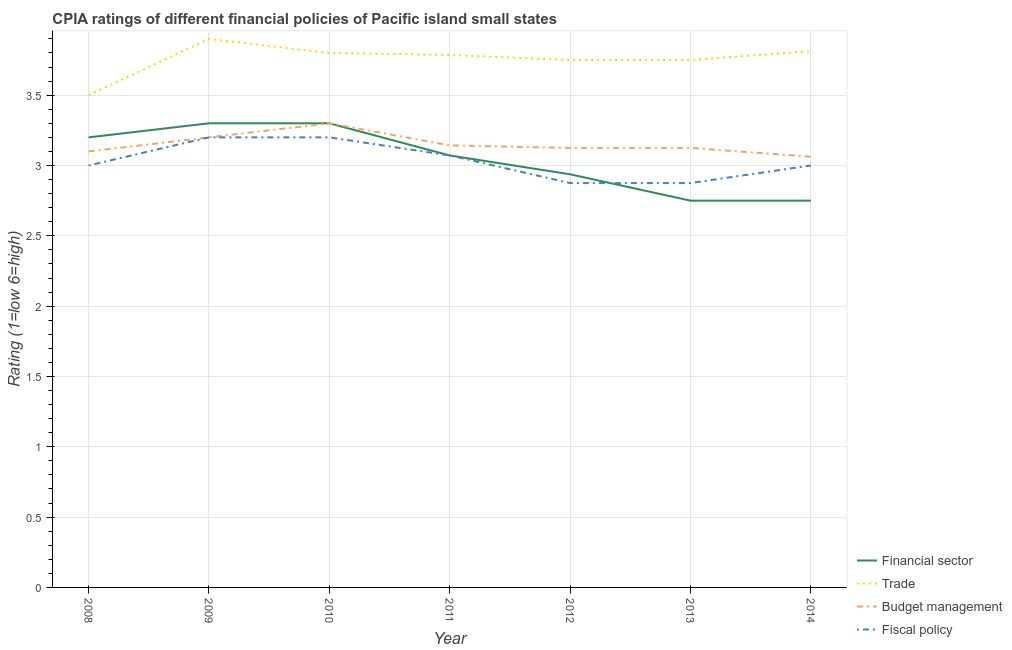How many different coloured lines are there?
Make the answer very short. 4. Is the number of lines equal to the number of legend labels?
Your response must be concise. Yes. Across all years, what is the maximum cpia rating of fiscal policy?
Ensure brevity in your answer.  3.2. What is the total cpia rating of budget management in the graph?
Ensure brevity in your answer.  22.06. What is the difference between the cpia rating of fiscal policy in 2009 and that in 2013?
Provide a succinct answer. 0.33. What is the difference between the cpia rating of fiscal policy in 2009 and the cpia rating of trade in 2010?
Offer a very short reply. -0.6. What is the average cpia rating of financial sector per year?
Your response must be concise. 3.04. In the year 2010, what is the difference between the cpia rating of fiscal policy and cpia rating of financial sector?
Provide a succinct answer. -0.1. What is the ratio of the cpia rating of budget management in 2010 to that in 2012?
Offer a terse response. 1.06. Is the cpia rating of trade in 2011 less than that in 2013?
Make the answer very short. No. Is the difference between the cpia rating of financial sector in 2008 and 2011 greater than the difference between the cpia rating of trade in 2008 and 2011?
Ensure brevity in your answer.  Yes. What is the difference between the highest and the second highest cpia rating of trade?
Your answer should be very brief. 0.09. What is the difference between the highest and the lowest cpia rating of financial sector?
Keep it short and to the point. 0.55. Is the sum of the cpia rating of budget management in 2010 and 2012 greater than the maximum cpia rating of fiscal policy across all years?
Make the answer very short. Yes. Is it the case that in every year, the sum of the cpia rating of financial sector and cpia rating of trade is greater than the cpia rating of budget management?
Your answer should be compact. Yes. Does the cpia rating of fiscal policy monotonically increase over the years?
Offer a very short reply. No. Is the cpia rating of trade strictly less than the cpia rating of financial sector over the years?
Offer a very short reply. No. How many years are there in the graph?
Make the answer very short. 7. Does the graph contain grids?
Your answer should be very brief. Yes. Where does the legend appear in the graph?
Keep it short and to the point. Bottom right. How are the legend labels stacked?
Offer a very short reply. Vertical. What is the title of the graph?
Offer a very short reply. CPIA ratings of different financial policies of Pacific island small states. Does "Finland" appear as one of the legend labels in the graph?
Offer a very short reply. No. What is the label or title of the X-axis?
Keep it short and to the point. Year. What is the label or title of the Y-axis?
Your answer should be compact. Rating (1=low 6=high). What is the Rating (1=low 6=high) in Budget management in 2008?
Your answer should be compact. 3.1. What is the Rating (1=low 6=high) of Budget management in 2009?
Your response must be concise. 3.2. What is the Rating (1=low 6=high) of Fiscal policy in 2009?
Make the answer very short. 3.2. What is the Rating (1=low 6=high) of Financial sector in 2010?
Make the answer very short. 3.3. What is the Rating (1=low 6=high) of Budget management in 2010?
Your answer should be very brief. 3.3. What is the Rating (1=low 6=high) in Fiscal policy in 2010?
Offer a terse response. 3.2. What is the Rating (1=low 6=high) of Financial sector in 2011?
Offer a very short reply. 3.07. What is the Rating (1=low 6=high) of Trade in 2011?
Offer a very short reply. 3.79. What is the Rating (1=low 6=high) of Budget management in 2011?
Offer a very short reply. 3.14. What is the Rating (1=low 6=high) in Fiscal policy in 2011?
Offer a terse response. 3.07. What is the Rating (1=low 6=high) in Financial sector in 2012?
Your response must be concise. 2.94. What is the Rating (1=low 6=high) of Trade in 2012?
Your answer should be very brief. 3.75. What is the Rating (1=low 6=high) in Budget management in 2012?
Your answer should be compact. 3.12. What is the Rating (1=low 6=high) in Fiscal policy in 2012?
Provide a short and direct response. 2.88. What is the Rating (1=low 6=high) of Financial sector in 2013?
Offer a terse response. 2.75. What is the Rating (1=low 6=high) in Trade in 2013?
Offer a very short reply. 3.75. What is the Rating (1=low 6=high) of Budget management in 2013?
Your answer should be very brief. 3.12. What is the Rating (1=low 6=high) in Fiscal policy in 2013?
Offer a very short reply. 2.88. What is the Rating (1=low 6=high) of Financial sector in 2014?
Provide a succinct answer. 2.75. What is the Rating (1=low 6=high) of Trade in 2014?
Your answer should be compact. 3.81. What is the Rating (1=low 6=high) in Budget management in 2014?
Give a very brief answer. 3.06. Across all years, what is the maximum Rating (1=low 6=high) of Financial sector?
Offer a very short reply. 3.3. Across all years, what is the maximum Rating (1=low 6=high) in Budget management?
Make the answer very short. 3.3. Across all years, what is the minimum Rating (1=low 6=high) of Financial sector?
Your answer should be compact. 2.75. Across all years, what is the minimum Rating (1=low 6=high) of Trade?
Ensure brevity in your answer.  3.5. Across all years, what is the minimum Rating (1=low 6=high) of Budget management?
Provide a short and direct response. 3.06. Across all years, what is the minimum Rating (1=low 6=high) of Fiscal policy?
Offer a very short reply. 2.88. What is the total Rating (1=low 6=high) of Financial sector in the graph?
Your answer should be compact. 21.31. What is the total Rating (1=low 6=high) of Trade in the graph?
Offer a terse response. 26.3. What is the total Rating (1=low 6=high) in Budget management in the graph?
Offer a very short reply. 22.06. What is the total Rating (1=low 6=high) of Fiscal policy in the graph?
Make the answer very short. 21.22. What is the difference between the Rating (1=low 6=high) in Financial sector in 2008 and that in 2009?
Your answer should be compact. -0.1. What is the difference between the Rating (1=low 6=high) in Fiscal policy in 2008 and that in 2009?
Your answer should be very brief. -0.2. What is the difference between the Rating (1=low 6=high) in Budget management in 2008 and that in 2010?
Your answer should be compact. -0.2. What is the difference between the Rating (1=low 6=high) in Fiscal policy in 2008 and that in 2010?
Offer a very short reply. -0.2. What is the difference between the Rating (1=low 6=high) in Financial sector in 2008 and that in 2011?
Your answer should be compact. 0.13. What is the difference between the Rating (1=low 6=high) in Trade in 2008 and that in 2011?
Offer a very short reply. -0.29. What is the difference between the Rating (1=low 6=high) in Budget management in 2008 and that in 2011?
Make the answer very short. -0.04. What is the difference between the Rating (1=low 6=high) of Fiscal policy in 2008 and that in 2011?
Offer a terse response. -0.07. What is the difference between the Rating (1=low 6=high) of Financial sector in 2008 and that in 2012?
Offer a very short reply. 0.26. What is the difference between the Rating (1=low 6=high) of Trade in 2008 and that in 2012?
Ensure brevity in your answer.  -0.25. What is the difference between the Rating (1=low 6=high) in Budget management in 2008 and that in 2012?
Your answer should be compact. -0.03. What is the difference between the Rating (1=low 6=high) of Financial sector in 2008 and that in 2013?
Provide a short and direct response. 0.45. What is the difference between the Rating (1=low 6=high) of Budget management in 2008 and that in 2013?
Provide a short and direct response. -0.03. What is the difference between the Rating (1=low 6=high) of Financial sector in 2008 and that in 2014?
Provide a short and direct response. 0.45. What is the difference between the Rating (1=low 6=high) of Trade in 2008 and that in 2014?
Your response must be concise. -0.31. What is the difference between the Rating (1=low 6=high) of Budget management in 2008 and that in 2014?
Offer a very short reply. 0.04. What is the difference between the Rating (1=low 6=high) of Fiscal policy in 2008 and that in 2014?
Your answer should be very brief. 0. What is the difference between the Rating (1=low 6=high) of Trade in 2009 and that in 2010?
Keep it short and to the point. 0.1. What is the difference between the Rating (1=low 6=high) in Financial sector in 2009 and that in 2011?
Your response must be concise. 0.23. What is the difference between the Rating (1=low 6=high) of Trade in 2009 and that in 2011?
Your response must be concise. 0.11. What is the difference between the Rating (1=low 6=high) in Budget management in 2009 and that in 2011?
Give a very brief answer. 0.06. What is the difference between the Rating (1=low 6=high) in Fiscal policy in 2009 and that in 2011?
Keep it short and to the point. 0.13. What is the difference between the Rating (1=low 6=high) in Financial sector in 2009 and that in 2012?
Your answer should be very brief. 0.36. What is the difference between the Rating (1=low 6=high) of Budget management in 2009 and that in 2012?
Keep it short and to the point. 0.07. What is the difference between the Rating (1=low 6=high) of Fiscal policy in 2009 and that in 2012?
Provide a short and direct response. 0.33. What is the difference between the Rating (1=low 6=high) of Financial sector in 2009 and that in 2013?
Keep it short and to the point. 0.55. What is the difference between the Rating (1=low 6=high) in Trade in 2009 and that in 2013?
Your answer should be compact. 0.15. What is the difference between the Rating (1=low 6=high) of Budget management in 2009 and that in 2013?
Your answer should be compact. 0.07. What is the difference between the Rating (1=low 6=high) in Fiscal policy in 2009 and that in 2013?
Your response must be concise. 0.33. What is the difference between the Rating (1=low 6=high) of Financial sector in 2009 and that in 2014?
Your answer should be very brief. 0.55. What is the difference between the Rating (1=low 6=high) of Trade in 2009 and that in 2014?
Give a very brief answer. 0.09. What is the difference between the Rating (1=low 6=high) of Budget management in 2009 and that in 2014?
Your response must be concise. 0.14. What is the difference between the Rating (1=low 6=high) in Fiscal policy in 2009 and that in 2014?
Ensure brevity in your answer.  0.2. What is the difference between the Rating (1=low 6=high) of Financial sector in 2010 and that in 2011?
Make the answer very short. 0.23. What is the difference between the Rating (1=low 6=high) of Trade in 2010 and that in 2011?
Provide a short and direct response. 0.01. What is the difference between the Rating (1=low 6=high) of Budget management in 2010 and that in 2011?
Your answer should be compact. 0.16. What is the difference between the Rating (1=low 6=high) of Fiscal policy in 2010 and that in 2011?
Keep it short and to the point. 0.13. What is the difference between the Rating (1=low 6=high) in Financial sector in 2010 and that in 2012?
Your answer should be very brief. 0.36. What is the difference between the Rating (1=low 6=high) in Budget management in 2010 and that in 2012?
Keep it short and to the point. 0.17. What is the difference between the Rating (1=low 6=high) in Fiscal policy in 2010 and that in 2012?
Ensure brevity in your answer.  0.33. What is the difference between the Rating (1=low 6=high) in Financial sector in 2010 and that in 2013?
Keep it short and to the point. 0.55. What is the difference between the Rating (1=low 6=high) of Trade in 2010 and that in 2013?
Give a very brief answer. 0.05. What is the difference between the Rating (1=low 6=high) in Budget management in 2010 and that in 2013?
Offer a very short reply. 0.17. What is the difference between the Rating (1=low 6=high) of Fiscal policy in 2010 and that in 2013?
Ensure brevity in your answer.  0.33. What is the difference between the Rating (1=low 6=high) in Financial sector in 2010 and that in 2014?
Provide a succinct answer. 0.55. What is the difference between the Rating (1=low 6=high) of Trade in 2010 and that in 2014?
Make the answer very short. -0.01. What is the difference between the Rating (1=low 6=high) of Budget management in 2010 and that in 2014?
Make the answer very short. 0.24. What is the difference between the Rating (1=low 6=high) of Fiscal policy in 2010 and that in 2014?
Provide a succinct answer. 0.2. What is the difference between the Rating (1=low 6=high) in Financial sector in 2011 and that in 2012?
Make the answer very short. 0.13. What is the difference between the Rating (1=low 6=high) of Trade in 2011 and that in 2012?
Make the answer very short. 0.04. What is the difference between the Rating (1=low 6=high) in Budget management in 2011 and that in 2012?
Offer a very short reply. 0.02. What is the difference between the Rating (1=low 6=high) in Fiscal policy in 2011 and that in 2012?
Ensure brevity in your answer.  0.2. What is the difference between the Rating (1=low 6=high) of Financial sector in 2011 and that in 2013?
Keep it short and to the point. 0.32. What is the difference between the Rating (1=low 6=high) in Trade in 2011 and that in 2013?
Provide a succinct answer. 0.04. What is the difference between the Rating (1=low 6=high) of Budget management in 2011 and that in 2013?
Provide a short and direct response. 0.02. What is the difference between the Rating (1=low 6=high) of Fiscal policy in 2011 and that in 2013?
Your answer should be very brief. 0.2. What is the difference between the Rating (1=low 6=high) of Financial sector in 2011 and that in 2014?
Your response must be concise. 0.32. What is the difference between the Rating (1=low 6=high) of Trade in 2011 and that in 2014?
Your answer should be very brief. -0.03. What is the difference between the Rating (1=low 6=high) of Budget management in 2011 and that in 2014?
Your answer should be compact. 0.08. What is the difference between the Rating (1=low 6=high) in Fiscal policy in 2011 and that in 2014?
Your answer should be very brief. 0.07. What is the difference between the Rating (1=low 6=high) of Financial sector in 2012 and that in 2013?
Offer a terse response. 0.19. What is the difference between the Rating (1=low 6=high) of Fiscal policy in 2012 and that in 2013?
Offer a terse response. 0. What is the difference between the Rating (1=low 6=high) in Financial sector in 2012 and that in 2014?
Provide a succinct answer. 0.19. What is the difference between the Rating (1=low 6=high) in Trade in 2012 and that in 2014?
Offer a very short reply. -0.06. What is the difference between the Rating (1=low 6=high) in Budget management in 2012 and that in 2014?
Give a very brief answer. 0.06. What is the difference between the Rating (1=low 6=high) in Fiscal policy in 2012 and that in 2014?
Offer a terse response. -0.12. What is the difference between the Rating (1=low 6=high) in Trade in 2013 and that in 2014?
Offer a very short reply. -0.06. What is the difference between the Rating (1=low 6=high) of Budget management in 2013 and that in 2014?
Offer a terse response. 0.06. What is the difference between the Rating (1=low 6=high) of Fiscal policy in 2013 and that in 2014?
Provide a short and direct response. -0.12. What is the difference between the Rating (1=low 6=high) of Financial sector in 2008 and the Rating (1=low 6=high) of Budget management in 2009?
Offer a terse response. 0. What is the difference between the Rating (1=low 6=high) in Financial sector in 2008 and the Rating (1=low 6=high) in Fiscal policy in 2009?
Give a very brief answer. 0. What is the difference between the Rating (1=low 6=high) of Trade in 2008 and the Rating (1=low 6=high) of Fiscal policy in 2009?
Your answer should be compact. 0.3. What is the difference between the Rating (1=low 6=high) in Financial sector in 2008 and the Rating (1=low 6=high) in Fiscal policy in 2010?
Offer a very short reply. 0. What is the difference between the Rating (1=low 6=high) in Trade in 2008 and the Rating (1=low 6=high) in Budget management in 2010?
Your answer should be very brief. 0.2. What is the difference between the Rating (1=low 6=high) in Trade in 2008 and the Rating (1=low 6=high) in Fiscal policy in 2010?
Provide a short and direct response. 0.3. What is the difference between the Rating (1=low 6=high) of Financial sector in 2008 and the Rating (1=low 6=high) of Trade in 2011?
Ensure brevity in your answer.  -0.59. What is the difference between the Rating (1=low 6=high) of Financial sector in 2008 and the Rating (1=low 6=high) of Budget management in 2011?
Your response must be concise. 0.06. What is the difference between the Rating (1=low 6=high) in Financial sector in 2008 and the Rating (1=low 6=high) in Fiscal policy in 2011?
Offer a very short reply. 0.13. What is the difference between the Rating (1=low 6=high) of Trade in 2008 and the Rating (1=low 6=high) of Budget management in 2011?
Ensure brevity in your answer.  0.36. What is the difference between the Rating (1=low 6=high) of Trade in 2008 and the Rating (1=low 6=high) of Fiscal policy in 2011?
Your answer should be very brief. 0.43. What is the difference between the Rating (1=low 6=high) of Budget management in 2008 and the Rating (1=low 6=high) of Fiscal policy in 2011?
Provide a short and direct response. 0.03. What is the difference between the Rating (1=low 6=high) of Financial sector in 2008 and the Rating (1=low 6=high) of Trade in 2012?
Your response must be concise. -0.55. What is the difference between the Rating (1=low 6=high) of Financial sector in 2008 and the Rating (1=low 6=high) of Budget management in 2012?
Make the answer very short. 0.07. What is the difference between the Rating (1=low 6=high) in Financial sector in 2008 and the Rating (1=low 6=high) in Fiscal policy in 2012?
Provide a succinct answer. 0.33. What is the difference between the Rating (1=low 6=high) of Trade in 2008 and the Rating (1=low 6=high) of Fiscal policy in 2012?
Offer a very short reply. 0.62. What is the difference between the Rating (1=low 6=high) of Budget management in 2008 and the Rating (1=low 6=high) of Fiscal policy in 2012?
Offer a very short reply. 0.23. What is the difference between the Rating (1=low 6=high) in Financial sector in 2008 and the Rating (1=low 6=high) in Trade in 2013?
Make the answer very short. -0.55. What is the difference between the Rating (1=low 6=high) of Financial sector in 2008 and the Rating (1=low 6=high) of Budget management in 2013?
Offer a terse response. 0.07. What is the difference between the Rating (1=low 6=high) in Financial sector in 2008 and the Rating (1=low 6=high) in Fiscal policy in 2013?
Your answer should be very brief. 0.33. What is the difference between the Rating (1=low 6=high) of Trade in 2008 and the Rating (1=low 6=high) of Fiscal policy in 2013?
Your answer should be compact. 0.62. What is the difference between the Rating (1=low 6=high) in Budget management in 2008 and the Rating (1=low 6=high) in Fiscal policy in 2013?
Provide a succinct answer. 0.23. What is the difference between the Rating (1=low 6=high) in Financial sector in 2008 and the Rating (1=low 6=high) in Trade in 2014?
Your response must be concise. -0.61. What is the difference between the Rating (1=low 6=high) in Financial sector in 2008 and the Rating (1=low 6=high) in Budget management in 2014?
Offer a terse response. 0.14. What is the difference between the Rating (1=low 6=high) of Trade in 2008 and the Rating (1=low 6=high) of Budget management in 2014?
Keep it short and to the point. 0.44. What is the difference between the Rating (1=low 6=high) of Financial sector in 2009 and the Rating (1=low 6=high) of Trade in 2010?
Make the answer very short. -0.5. What is the difference between the Rating (1=low 6=high) of Trade in 2009 and the Rating (1=low 6=high) of Fiscal policy in 2010?
Your response must be concise. 0.7. What is the difference between the Rating (1=low 6=high) in Financial sector in 2009 and the Rating (1=low 6=high) in Trade in 2011?
Your answer should be compact. -0.49. What is the difference between the Rating (1=low 6=high) in Financial sector in 2009 and the Rating (1=low 6=high) in Budget management in 2011?
Ensure brevity in your answer.  0.16. What is the difference between the Rating (1=low 6=high) of Financial sector in 2009 and the Rating (1=low 6=high) of Fiscal policy in 2011?
Provide a succinct answer. 0.23. What is the difference between the Rating (1=low 6=high) of Trade in 2009 and the Rating (1=low 6=high) of Budget management in 2011?
Ensure brevity in your answer.  0.76. What is the difference between the Rating (1=low 6=high) of Trade in 2009 and the Rating (1=low 6=high) of Fiscal policy in 2011?
Your response must be concise. 0.83. What is the difference between the Rating (1=low 6=high) of Budget management in 2009 and the Rating (1=low 6=high) of Fiscal policy in 2011?
Ensure brevity in your answer.  0.13. What is the difference between the Rating (1=low 6=high) in Financial sector in 2009 and the Rating (1=low 6=high) in Trade in 2012?
Your response must be concise. -0.45. What is the difference between the Rating (1=low 6=high) of Financial sector in 2009 and the Rating (1=low 6=high) of Budget management in 2012?
Provide a short and direct response. 0.17. What is the difference between the Rating (1=low 6=high) in Financial sector in 2009 and the Rating (1=low 6=high) in Fiscal policy in 2012?
Your answer should be very brief. 0.42. What is the difference between the Rating (1=low 6=high) in Trade in 2009 and the Rating (1=low 6=high) in Budget management in 2012?
Make the answer very short. 0.78. What is the difference between the Rating (1=low 6=high) in Budget management in 2009 and the Rating (1=low 6=high) in Fiscal policy in 2012?
Your response must be concise. 0.33. What is the difference between the Rating (1=low 6=high) in Financial sector in 2009 and the Rating (1=low 6=high) in Trade in 2013?
Provide a short and direct response. -0.45. What is the difference between the Rating (1=low 6=high) in Financial sector in 2009 and the Rating (1=low 6=high) in Budget management in 2013?
Keep it short and to the point. 0.17. What is the difference between the Rating (1=low 6=high) in Financial sector in 2009 and the Rating (1=low 6=high) in Fiscal policy in 2013?
Provide a succinct answer. 0.42. What is the difference between the Rating (1=low 6=high) of Trade in 2009 and the Rating (1=low 6=high) of Budget management in 2013?
Your answer should be very brief. 0.78. What is the difference between the Rating (1=low 6=high) of Trade in 2009 and the Rating (1=low 6=high) of Fiscal policy in 2013?
Make the answer very short. 1.02. What is the difference between the Rating (1=low 6=high) in Budget management in 2009 and the Rating (1=low 6=high) in Fiscal policy in 2013?
Offer a terse response. 0.33. What is the difference between the Rating (1=low 6=high) in Financial sector in 2009 and the Rating (1=low 6=high) in Trade in 2014?
Ensure brevity in your answer.  -0.51. What is the difference between the Rating (1=low 6=high) in Financial sector in 2009 and the Rating (1=low 6=high) in Budget management in 2014?
Make the answer very short. 0.24. What is the difference between the Rating (1=low 6=high) in Trade in 2009 and the Rating (1=low 6=high) in Budget management in 2014?
Your answer should be very brief. 0.84. What is the difference between the Rating (1=low 6=high) of Financial sector in 2010 and the Rating (1=low 6=high) of Trade in 2011?
Your answer should be compact. -0.49. What is the difference between the Rating (1=low 6=high) of Financial sector in 2010 and the Rating (1=low 6=high) of Budget management in 2011?
Your response must be concise. 0.16. What is the difference between the Rating (1=low 6=high) of Financial sector in 2010 and the Rating (1=low 6=high) of Fiscal policy in 2011?
Offer a terse response. 0.23. What is the difference between the Rating (1=low 6=high) in Trade in 2010 and the Rating (1=low 6=high) in Budget management in 2011?
Keep it short and to the point. 0.66. What is the difference between the Rating (1=low 6=high) in Trade in 2010 and the Rating (1=low 6=high) in Fiscal policy in 2011?
Your response must be concise. 0.73. What is the difference between the Rating (1=low 6=high) of Budget management in 2010 and the Rating (1=low 6=high) of Fiscal policy in 2011?
Make the answer very short. 0.23. What is the difference between the Rating (1=low 6=high) in Financial sector in 2010 and the Rating (1=low 6=high) in Trade in 2012?
Provide a succinct answer. -0.45. What is the difference between the Rating (1=low 6=high) of Financial sector in 2010 and the Rating (1=low 6=high) of Budget management in 2012?
Provide a succinct answer. 0.17. What is the difference between the Rating (1=low 6=high) of Financial sector in 2010 and the Rating (1=low 6=high) of Fiscal policy in 2012?
Offer a terse response. 0.42. What is the difference between the Rating (1=low 6=high) of Trade in 2010 and the Rating (1=low 6=high) of Budget management in 2012?
Keep it short and to the point. 0.68. What is the difference between the Rating (1=low 6=high) of Trade in 2010 and the Rating (1=low 6=high) of Fiscal policy in 2012?
Your answer should be very brief. 0.93. What is the difference between the Rating (1=low 6=high) of Budget management in 2010 and the Rating (1=low 6=high) of Fiscal policy in 2012?
Keep it short and to the point. 0.42. What is the difference between the Rating (1=low 6=high) in Financial sector in 2010 and the Rating (1=low 6=high) in Trade in 2013?
Your answer should be compact. -0.45. What is the difference between the Rating (1=low 6=high) of Financial sector in 2010 and the Rating (1=low 6=high) of Budget management in 2013?
Your answer should be very brief. 0.17. What is the difference between the Rating (1=low 6=high) of Financial sector in 2010 and the Rating (1=low 6=high) of Fiscal policy in 2013?
Ensure brevity in your answer.  0.42. What is the difference between the Rating (1=low 6=high) of Trade in 2010 and the Rating (1=low 6=high) of Budget management in 2013?
Make the answer very short. 0.68. What is the difference between the Rating (1=low 6=high) of Trade in 2010 and the Rating (1=low 6=high) of Fiscal policy in 2013?
Give a very brief answer. 0.93. What is the difference between the Rating (1=low 6=high) in Budget management in 2010 and the Rating (1=low 6=high) in Fiscal policy in 2013?
Your answer should be compact. 0.42. What is the difference between the Rating (1=low 6=high) of Financial sector in 2010 and the Rating (1=low 6=high) of Trade in 2014?
Provide a succinct answer. -0.51. What is the difference between the Rating (1=low 6=high) in Financial sector in 2010 and the Rating (1=low 6=high) in Budget management in 2014?
Make the answer very short. 0.24. What is the difference between the Rating (1=low 6=high) of Financial sector in 2010 and the Rating (1=low 6=high) of Fiscal policy in 2014?
Your answer should be compact. 0.3. What is the difference between the Rating (1=low 6=high) of Trade in 2010 and the Rating (1=low 6=high) of Budget management in 2014?
Provide a short and direct response. 0.74. What is the difference between the Rating (1=low 6=high) in Trade in 2010 and the Rating (1=low 6=high) in Fiscal policy in 2014?
Ensure brevity in your answer.  0.8. What is the difference between the Rating (1=low 6=high) in Budget management in 2010 and the Rating (1=low 6=high) in Fiscal policy in 2014?
Your response must be concise. 0.3. What is the difference between the Rating (1=low 6=high) of Financial sector in 2011 and the Rating (1=low 6=high) of Trade in 2012?
Your response must be concise. -0.68. What is the difference between the Rating (1=low 6=high) of Financial sector in 2011 and the Rating (1=low 6=high) of Budget management in 2012?
Ensure brevity in your answer.  -0.05. What is the difference between the Rating (1=low 6=high) of Financial sector in 2011 and the Rating (1=low 6=high) of Fiscal policy in 2012?
Your response must be concise. 0.2. What is the difference between the Rating (1=low 6=high) in Trade in 2011 and the Rating (1=low 6=high) in Budget management in 2012?
Offer a terse response. 0.66. What is the difference between the Rating (1=low 6=high) in Trade in 2011 and the Rating (1=low 6=high) in Fiscal policy in 2012?
Provide a succinct answer. 0.91. What is the difference between the Rating (1=low 6=high) in Budget management in 2011 and the Rating (1=low 6=high) in Fiscal policy in 2012?
Your answer should be compact. 0.27. What is the difference between the Rating (1=low 6=high) of Financial sector in 2011 and the Rating (1=low 6=high) of Trade in 2013?
Your response must be concise. -0.68. What is the difference between the Rating (1=low 6=high) of Financial sector in 2011 and the Rating (1=low 6=high) of Budget management in 2013?
Offer a very short reply. -0.05. What is the difference between the Rating (1=low 6=high) of Financial sector in 2011 and the Rating (1=low 6=high) of Fiscal policy in 2013?
Keep it short and to the point. 0.2. What is the difference between the Rating (1=low 6=high) of Trade in 2011 and the Rating (1=low 6=high) of Budget management in 2013?
Your answer should be compact. 0.66. What is the difference between the Rating (1=low 6=high) of Trade in 2011 and the Rating (1=low 6=high) of Fiscal policy in 2013?
Offer a very short reply. 0.91. What is the difference between the Rating (1=low 6=high) in Budget management in 2011 and the Rating (1=low 6=high) in Fiscal policy in 2013?
Your answer should be compact. 0.27. What is the difference between the Rating (1=low 6=high) of Financial sector in 2011 and the Rating (1=low 6=high) of Trade in 2014?
Make the answer very short. -0.74. What is the difference between the Rating (1=low 6=high) in Financial sector in 2011 and the Rating (1=low 6=high) in Budget management in 2014?
Ensure brevity in your answer.  0.01. What is the difference between the Rating (1=low 6=high) of Financial sector in 2011 and the Rating (1=low 6=high) of Fiscal policy in 2014?
Offer a very short reply. 0.07. What is the difference between the Rating (1=low 6=high) in Trade in 2011 and the Rating (1=low 6=high) in Budget management in 2014?
Give a very brief answer. 0.72. What is the difference between the Rating (1=low 6=high) in Trade in 2011 and the Rating (1=low 6=high) in Fiscal policy in 2014?
Ensure brevity in your answer.  0.79. What is the difference between the Rating (1=low 6=high) of Budget management in 2011 and the Rating (1=low 6=high) of Fiscal policy in 2014?
Ensure brevity in your answer.  0.14. What is the difference between the Rating (1=low 6=high) in Financial sector in 2012 and the Rating (1=low 6=high) in Trade in 2013?
Your answer should be compact. -0.81. What is the difference between the Rating (1=low 6=high) in Financial sector in 2012 and the Rating (1=low 6=high) in Budget management in 2013?
Give a very brief answer. -0.19. What is the difference between the Rating (1=low 6=high) of Financial sector in 2012 and the Rating (1=low 6=high) of Fiscal policy in 2013?
Offer a very short reply. 0.06. What is the difference between the Rating (1=low 6=high) in Trade in 2012 and the Rating (1=low 6=high) in Budget management in 2013?
Your answer should be compact. 0.62. What is the difference between the Rating (1=low 6=high) of Financial sector in 2012 and the Rating (1=low 6=high) of Trade in 2014?
Make the answer very short. -0.88. What is the difference between the Rating (1=low 6=high) of Financial sector in 2012 and the Rating (1=low 6=high) of Budget management in 2014?
Provide a short and direct response. -0.12. What is the difference between the Rating (1=low 6=high) in Financial sector in 2012 and the Rating (1=low 6=high) in Fiscal policy in 2014?
Offer a very short reply. -0.06. What is the difference between the Rating (1=low 6=high) in Trade in 2012 and the Rating (1=low 6=high) in Budget management in 2014?
Your response must be concise. 0.69. What is the difference between the Rating (1=low 6=high) in Trade in 2012 and the Rating (1=low 6=high) in Fiscal policy in 2014?
Your answer should be compact. 0.75. What is the difference between the Rating (1=low 6=high) of Financial sector in 2013 and the Rating (1=low 6=high) of Trade in 2014?
Give a very brief answer. -1.06. What is the difference between the Rating (1=low 6=high) in Financial sector in 2013 and the Rating (1=low 6=high) in Budget management in 2014?
Provide a succinct answer. -0.31. What is the difference between the Rating (1=low 6=high) in Financial sector in 2013 and the Rating (1=low 6=high) in Fiscal policy in 2014?
Your answer should be very brief. -0.25. What is the difference between the Rating (1=low 6=high) of Trade in 2013 and the Rating (1=low 6=high) of Budget management in 2014?
Provide a succinct answer. 0.69. What is the difference between the Rating (1=low 6=high) of Trade in 2013 and the Rating (1=low 6=high) of Fiscal policy in 2014?
Provide a short and direct response. 0.75. What is the difference between the Rating (1=low 6=high) of Budget management in 2013 and the Rating (1=low 6=high) of Fiscal policy in 2014?
Offer a very short reply. 0.12. What is the average Rating (1=low 6=high) of Financial sector per year?
Your answer should be compact. 3.04. What is the average Rating (1=low 6=high) of Trade per year?
Your response must be concise. 3.76. What is the average Rating (1=low 6=high) in Budget management per year?
Your response must be concise. 3.15. What is the average Rating (1=low 6=high) in Fiscal policy per year?
Make the answer very short. 3.03. In the year 2008, what is the difference between the Rating (1=low 6=high) of Financial sector and Rating (1=low 6=high) of Trade?
Give a very brief answer. -0.3. In the year 2008, what is the difference between the Rating (1=low 6=high) in Financial sector and Rating (1=low 6=high) in Fiscal policy?
Ensure brevity in your answer.  0.2. In the year 2008, what is the difference between the Rating (1=low 6=high) in Trade and Rating (1=low 6=high) in Fiscal policy?
Provide a short and direct response. 0.5. In the year 2009, what is the difference between the Rating (1=low 6=high) in Financial sector and Rating (1=low 6=high) in Trade?
Your answer should be very brief. -0.6. In the year 2009, what is the difference between the Rating (1=low 6=high) in Financial sector and Rating (1=low 6=high) in Budget management?
Offer a terse response. 0.1. In the year 2009, what is the difference between the Rating (1=low 6=high) in Financial sector and Rating (1=low 6=high) in Fiscal policy?
Provide a short and direct response. 0.1. In the year 2009, what is the difference between the Rating (1=low 6=high) in Trade and Rating (1=low 6=high) in Fiscal policy?
Give a very brief answer. 0.7. In the year 2010, what is the difference between the Rating (1=low 6=high) in Financial sector and Rating (1=low 6=high) in Budget management?
Provide a succinct answer. 0. In the year 2010, what is the difference between the Rating (1=low 6=high) of Financial sector and Rating (1=low 6=high) of Fiscal policy?
Your response must be concise. 0.1. In the year 2010, what is the difference between the Rating (1=low 6=high) of Budget management and Rating (1=low 6=high) of Fiscal policy?
Ensure brevity in your answer.  0.1. In the year 2011, what is the difference between the Rating (1=low 6=high) of Financial sector and Rating (1=low 6=high) of Trade?
Provide a short and direct response. -0.71. In the year 2011, what is the difference between the Rating (1=low 6=high) of Financial sector and Rating (1=low 6=high) of Budget management?
Ensure brevity in your answer.  -0.07. In the year 2011, what is the difference between the Rating (1=low 6=high) in Trade and Rating (1=low 6=high) in Budget management?
Offer a terse response. 0.64. In the year 2011, what is the difference between the Rating (1=low 6=high) in Budget management and Rating (1=low 6=high) in Fiscal policy?
Offer a very short reply. 0.07. In the year 2012, what is the difference between the Rating (1=low 6=high) of Financial sector and Rating (1=low 6=high) of Trade?
Your response must be concise. -0.81. In the year 2012, what is the difference between the Rating (1=low 6=high) in Financial sector and Rating (1=low 6=high) in Budget management?
Make the answer very short. -0.19. In the year 2012, what is the difference between the Rating (1=low 6=high) in Financial sector and Rating (1=low 6=high) in Fiscal policy?
Ensure brevity in your answer.  0.06. In the year 2012, what is the difference between the Rating (1=low 6=high) of Trade and Rating (1=low 6=high) of Budget management?
Make the answer very short. 0.62. In the year 2012, what is the difference between the Rating (1=low 6=high) of Trade and Rating (1=low 6=high) of Fiscal policy?
Offer a very short reply. 0.88. In the year 2013, what is the difference between the Rating (1=low 6=high) of Financial sector and Rating (1=low 6=high) of Trade?
Provide a succinct answer. -1. In the year 2013, what is the difference between the Rating (1=low 6=high) in Financial sector and Rating (1=low 6=high) in Budget management?
Give a very brief answer. -0.38. In the year 2013, what is the difference between the Rating (1=low 6=high) in Financial sector and Rating (1=low 6=high) in Fiscal policy?
Keep it short and to the point. -0.12. In the year 2013, what is the difference between the Rating (1=low 6=high) in Trade and Rating (1=low 6=high) in Budget management?
Make the answer very short. 0.62. In the year 2014, what is the difference between the Rating (1=low 6=high) in Financial sector and Rating (1=low 6=high) in Trade?
Keep it short and to the point. -1.06. In the year 2014, what is the difference between the Rating (1=low 6=high) of Financial sector and Rating (1=low 6=high) of Budget management?
Offer a very short reply. -0.31. In the year 2014, what is the difference between the Rating (1=low 6=high) in Financial sector and Rating (1=low 6=high) in Fiscal policy?
Your answer should be very brief. -0.25. In the year 2014, what is the difference between the Rating (1=low 6=high) of Trade and Rating (1=low 6=high) of Fiscal policy?
Make the answer very short. 0.81. In the year 2014, what is the difference between the Rating (1=low 6=high) in Budget management and Rating (1=low 6=high) in Fiscal policy?
Your answer should be very brief. 0.06. What is the ratio of the Rating (1=low 6=high) in Financial sector in 2008 to that in 2009?
Offer a very short reply. 0.97. What is the ratio of the Rating (1=low 6=high) of Trade in 2008 to that in 2009?
Offer a terse response. 0.9. What is the ratio of the Rating (1=low 6=high) of Budget management in 2008 to that in 2009?
Offer a terse response. 0.97. What is the ratio of the Rating (1=low 6=high) in Fiscal policy in 2008 to that in 2009?
Give a very brief answer. 0.94. What is the ratio of the Rating (1=low 6=high) in Financial sector in 2008 to that in 2010?
Your response must be concise. 0.97. What is the ratio of the Rating (1=low 6=high) of Trade in 2008 to that in 2010?
Provide a succinct answer. 0.92. What is the ratio of the Rating (1=low 6=high) of Budget management in 2008 to that in 2010?
Your answer should be compact. 0.94. What is the ratio of the Rating (1=low 6=high) of Financial sector in 2008 to that in 2011?
Your answer should be compact. 1.04. What is the ratio of the Rating (1=low 6=high) in Trade in 2008 to that in 2011?
Your answer should be compact. 0.92. What is the ratio of the Rating (1=low 6=high) in Budget management in 2008 to that in 2011?
Offer a terse response. 0.99. What is the ratio of the Rating (1=low 6=high) in Fiscal policy in 2008 to that in 2011?
Your answer should be compact. 0.98. What is the ratio of the Rating (1=low 6=high) in Financial sector in 2008 to that in 2012?
Provide a succinct answer. 1.09. What is the ratio of the Rating (1=low 6=high) of Fiscal policy in 2008 to that in 2012?
Provide a succinct answer. 1.04. What is the ratio of the Rating (1=low 6=high) in Financial sector in 2008 to that in 2013?
Give a very brief answer. 1.16. What is the ratio of the Rating (1=low 6=high) of Fiscal policy in 2008 to that in 2013?
Offer a terse response. 1.04. What is the ratio of the Rating (1=low 6=high) of Financial sector in 2008 to that in 2014?
Your answer should be compact. 1.16. What is the ratio of the Rating (1=low 6=high) of Trade in 2008 to that in 2014?
Ensure brevity in your answer.  0.92. What is the ratio of the Rating (1=low 6=high) in Budget management in 2008 to that in 2014?
Give a very brief answer. 1.01. What is the ratio of the Rating (1=low 6=high) of Fiscal policy in 2008 to that in 2014?
Provide a short and direct response. 1. What is the ratio of the Rating (1=low 6=high) in Trade in 2009 to that in 2010?
Your answer should be compact. 1.03. What is the ratio of the Rating (1=low 6=high) of Budget management in 2009 to that in 2010?
Your answer should be compact. 0.97. What is the ratio of the Rating (1=low 6=high) in Fiscal policy in 2009 to that in 2010?
Offer a terse response. 1. What is the ratio of the Rating (1=low 6=high) of Financial sector in 2009 to that in 2011?
Make the answer very short. 1.07. What is the ratio of the Rating (1=low 6=high) of Trade in 2009 to that in 2011?
Provide a short and direct response. 1.03. What is the ratio of the Rating (1=low 6=high) of Budget management in 2009 to that in 2011?
Provide a short and direct response. 1.02. What is the ratio of the Rating (1=low 6=high) in Fiscal policy in 2009 to that in 2011?
Provide a succinct answer. 1.04. What is the ratio of the Rating (1=low 6=high) in Financial sector in 2009 to that in 2012?
Make the answer very short. 1.12. What is the ratio of the Rating (1=low 6=high) in Trade in 2009 to that in 2012?
Keep it short and to the point. 1.04. What is the ratio of the Rating (1=low 6=high) of Fiscal policy in 2009 to that in 2012?
Provide a succinct answer. 1.11. What is the ratio of the Rating (1=low 6=high) in Fiscal policy in 2009 to that in 2013?
Ensure brevity in your answer.  1.11. What is the ratio of the Rating (1=low 6=high) in Trade in 2009 to that in 2014?
Provide a short and direct response. 1.02. What is the ratio of the Rating (1=low 6=high) of Budget management in 2009 to that in 2014?
Your response must be concise. 1.04. What is the ratio of the Rating (1=low 6=high) of Fiscal policy in 2009 to that in 2014?
Give a very brief answer. 1.07. What is the ratio of the Rating (1=low 6=high) in Financial sector in 2010 to that in 2011?
Provide a short and direct response. 1.07. What is the ratio of the Rating (1=low 6=high) in Fiscal policy in 2010 to that in 2011?
Ensure brevity in your answer.  1.04. What is the ratio of the Rating (1=low 6=high) in Financial sector in 2010 to that in 2012?
Your answer should be compact. 1.12. What is the ratio of the Rating (1=low 6=high) in Trade in 2010 to that in 2012?
Keep it short and to the point. 1.01. What is the ratio of the Rating (1=low 6=high) of Budget management in 2010 to that in 2012?
Make the answer very short. 1.06. What is the ratio of the Rating (1=low 6=high) of Fiscal policy in 2010 to that in 2012?
Your response must be concise. 1.11. What is the ratio of the Rating (1=low 6=high) of Trade in 2010 to that in 2013?
Provide a short and direct response. 1.01. What is the ratio of the Rating (1=low 6=high) in Budget management in 2010 to that in 2013?
Give a very brief answer. 1.06. What is the ratio of the Rating (1=low 6=high) of Fiscal policy in 2010 to that in 2013?
Provide a succinct answer. 1.11. What is the ratio of the Rating (1=low 6=high) in Trade in 2010 to that in 2014?
Your answer should be compact. 1. What is the ratio of the Rating (1=low 6=high) in Budget management in 2010 to that in 2014?
Ensure brevity in your answer.  1.08. What is the ratio of the Rating (1=low 6=high) in Fiscal policy in 2010 to that in 2014?
Give a very brief answer. 1.07. What is the ratio of the Rating (1=low 6=high) of Financial sector in 2011 to that in 2012?
Keep it short and to the point. 1.05. What is the ratio of the Rating (1=low 6=high) of Trade in 2011 to that in 2012?
Your answer should be compact. 1.01. What is the ratio of the Rating (1=low 6=high) of Budget management in 2011 to that in 2012?
Provide a succinct answer. 1.01. What is the ratio of the Rating (1=low 6=high) in Fiscal policy in 2011 to that in 2012?
Provide a short and direct response. 1.07. What is the ratio of the Rating (1=low 6=high) of Financial sector in 2011 to that in 2013?
Provide a short and direct response. 1.12. What is the ratio of the Rating (1=low 6=high) in Trade in 2011 to that in 2013?
Offer a very short reply. 1.01. What is the ratio of the Rating (1=low 6=high) in Budget management in 2011 to that in 2013?
Make the answer very short. 1.01. What is the ratio of the Rating (1=low 6=high) of Fiscal policy in 2011 to that in 2013?
Ensure brevity in your answer.  1.07. What is the ratio of the Rating (1=low 6=high) of Financial sector in 2011 to that in 2014?
Provide a succinct answer. 1.12. What is the ratio of the Rating (1=low 6=high) of Trade in 2011 to that in 2014?
Provide a short and direct response. 0.99. What is the ratio of the Rating (1=low 6=high) in Budget management in 2011 to that in 2014?
Keep it short and to the point. 1.03. What is the ratio of the Rating (1=low 6=high) in Fiscal policy in 2011 to that in 2014?
Your answer should be compact. 1.02. What is the ratio of the Rating (1=low 6=high) in Financial sector in 2012 to that in 2013?
Ensure brevity in your answer.  1.07. What is the ratio of the Rating (1=low 6=high) of Budget management in 2012 to that in 2013?
Give a very brief answer. 1. What is the ratio of the Rating (1=low 6=high) in Financial sector in 2012 to that in 2014?
Ensure brevity in your answer.  1.07. What is the ratio of the Rating (1=low 6=high) in Trade in 2012 to that in 2014?
Give a very brief answer. 0.98. What is the ratio of the Rating (1=low 6=high) in Budget management in 2012 to that in 2014?
Your answer should be very brief. 1.02. What is the ratio of the Rating (1=low 6=high) of Trade in 2013 to that in 2014?
Make the answer very short. 0.98. What is the ratio of the Rating (1=low 6=high) in Budget management in 2013 to that in 2014?
Ensure brevity in your answer.  1.02. What is the difference between the highest and the second highest Rating (1=low 6=high) in Financial sector?
Your answer should be very brief. 0. What is the difference between the highest and the second highest Rating (1=low 6=high) of Trade?
Ensure brevity in your answer.  0.09. What is the difference between the highest and the second highest Rating (1=low 6=high) of Fiscal policy?
Make the answer very short. 0. What is the difference between the highest and the lowest Rating (1=low 6=high) in Financial sector?
Keep it short and to the point. 0.55. What is the difference between the highest and the lowest Rating (1=low 6=high) of Trade?
Give a very brief answer. 0.4. What is the difference between the highest and the lowest Rating (1=low 6=high) in Budget management?
Your answer should be compact. 0.24. What is the difference between the highest and the lowest Rating (1=low 6=high) of Fiscal policy?
Provide a short and direct response. 0.33. 